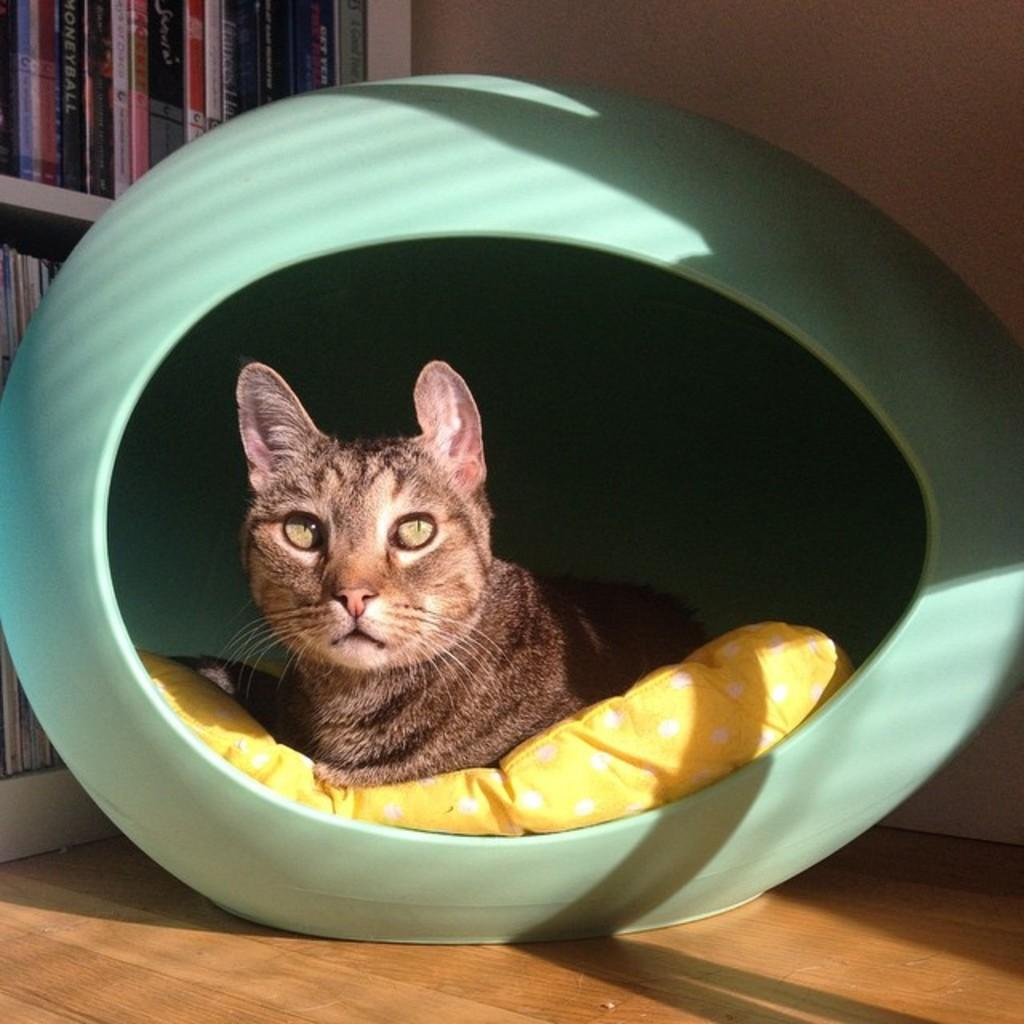What animal is present in the image? There is a cat in the image. Where is the cat located in the image? The cat is sitting in a cat house. What can be seen in the background of the image? There are books on shelves and a wall visible in the background of the image. What type of space exploration is the cat participating in within the image? There is no space exploration or any reference to space in the image; it features a cat sitting in a cat house. 